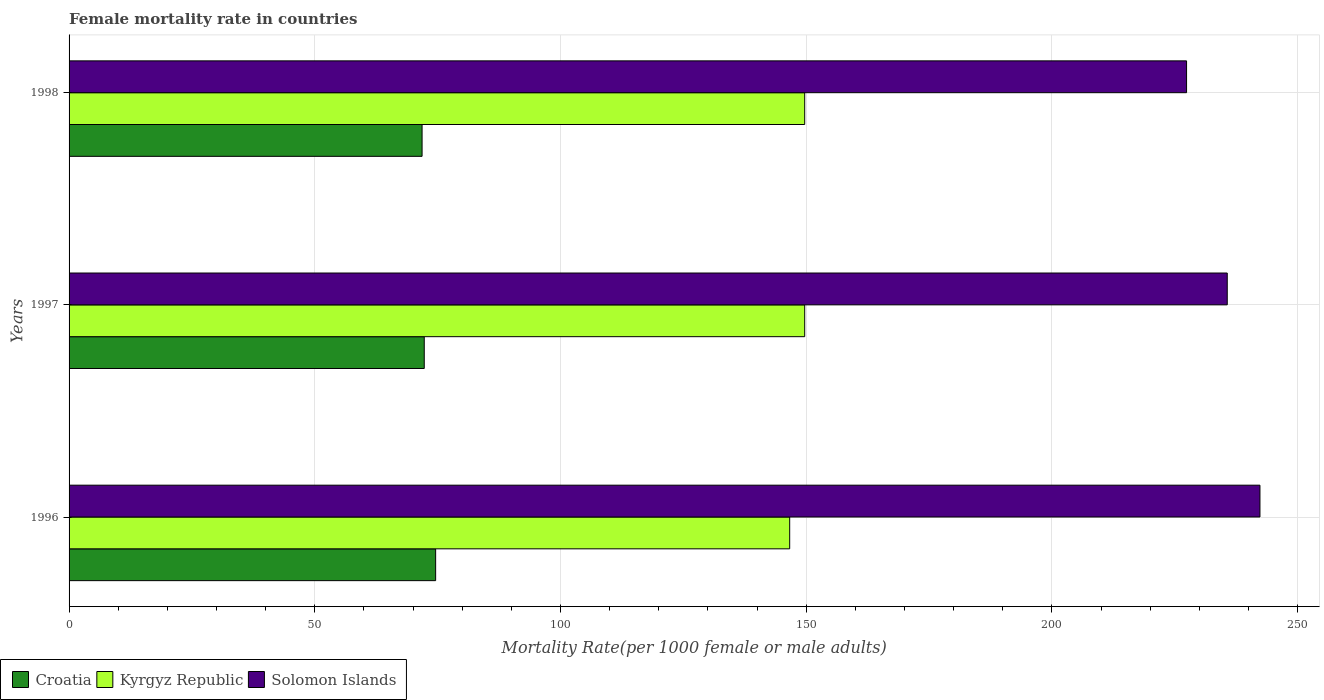How many groups of bars are there?
Give a very brief answer. 3. How many bars are there on the 2nd tick from the bottom?
Provide a succinct answer. 3. What is the label of the 3rd group of bars from the top?
Provide a short and direct response. 1996. In how many cases, is the number of bars for a given year not equal to the number of legend labels?
Your answer should be compact. 0. What is the female mortality rate in Solomon Islands in 1998?
Provide a succinct answer. 227.39. Across all years, what is the maximum female mortality rate in Solomon Islands?
Offer a terse response. 242.32. Across all years, what is the minimum female mortality rate in Croatia?
Offer a terse response. 71.83. In which year was the female mortality rate in Kyrgyz Republic maximum?
Your response must be concise. 1997. What is the total female mortality rate in Croatia in the graph?
Your response must be concise. 218.69. What is the difference between the female mortality rate in Croatia in 1996 and that in 1997?
Your answer should be very brief. 2.32. What is the difference between the female mortality rate in Kyrgyz Republic in 1996 and the female mortality rate in Croatia in 1998?
Ensure brevity in your answer.  74.8. What is the average female mortality rate in Solomon Islands per year?
Keep it short and to the point. 235.12. In the year 1997, what is the difference between the female mortality rate in Croatia and female mortality rate in Solomon Islands?
Your response must be concise. -163.39. What is the ratio of the female mortality rate in Croatia in 1997 to that in 1998?
Keep it short and to the point. 1.01. Is the female mortality rate in Kyrgyz Republic in 1997 less than that in 1998?
Ensure brevity in your answer.  No. What is the difference between the highest and the second highest female mortality rate in Solomon Islands?
Give a very brief answer. 6.66. What is the difference between the highest and the lowest female mortality rate in Solomon Islands?
Make the answer very short. 14.93. In how many years, is the female mortality rate in Solomon Islands greater than the average female mortality rate in Solomon Islands taken over all years?
Ensure brevity in your answer.  2. What does the 3rd bar from the top in 1997 represents?
Make the answer very short. Croatia. What does the 1st bar from the bottom in 1998 represents?
Your answer should be compact. Croatia. Is it the case that in every year, the sum of the female mortality rate in Croatia and female mortality rate in Kyrgyz Republic is greater than the female mortality rate in Solomon Islands?
Provide a short and direct response. No. How many years are there in the graph?
Your answer should be compact. 3. What is the difference between two consecutive major ticks on the X-axis?
Provide a short and direct response. 50. Are the values on the major ticks of X-axis written in scientific E-notation?
Keep it short and to the point. No. Does the graph contain grids?
Ensure brevity in your answer.  Yes. What is the title of the graph?
Provide a short and direct response. Female mortality rate in countries. Does "United States" appear as one of the legend labels in the graph?
Provide a short and direct response. No. What is the label or title of the X-axis?
Make the answer very short. Mortality Rate(per 1000 female or male adults). What is the Mortality Rate(per 1000 female or male adults) of Croatia in 1996?
Make the answer very short. 74.59. What is the Mortality Rate(per 1000 female or male adults) in Kyrgyz Republic in 1996?
Give a very brief answer. 146.63. What is the Mortality Rate(per 1000 female or male adults) in Solomon Islands in 1996?
Your answer should be compact. 242.32. What is the Mortality Rate(per 1000 female or male adults) in Croatia in 1997?
Ensure brevity in your answer.  72.27. What is the Mortality Rate(per 1000 female or male adults) in Kyrgyz Republic in 1997?
Your answer should be compact. 149.68. What is the Mortality Rate(per 1000 female or male adults) of Solomon Islands in 1997?
Provide a succinct answer. 235.66. What is the Mortality Rate(per 1000 female or male adults) of Croatia in 1998?
Provide a succinct answer. 71.83. What is the Mortality Rate(per 1000 female or male adults) of Kyrgyz Republic in 1998?
Provide a short and direct response. 149.68. What is the Mortality Rate(per 1000 female or male adults) in Solomon Islands in 1998?
Your answer should be compact. 227.39. Across all years, what is the maximum Mortality Rate(per 1000 female or male adults) of Croatia?
Your answer should be very brief. 74.59. Across all years, what is the maximum Mortality Rate(per 1000 female or male adults) of Kyrgyz Republic?
Make the answer very short. 149.68. Across all years, what is the maximum Mortality Rate(per 1000 female or male adults) in Solomon Islands?
Offer a very short reply. 242.32. Across all years, what is the minimum Mortality Rate(per 1000 female or male adults) in Croatia?
Your answer should be compact. 71.83. Across all years, what is the minimum Mortality Rate(per 1000 female or male adults) in Kyrgyz Republic?
Keep it short and to the point. 146.63. Across all years, what is the minimum Mortality Rate(per 1000 female or male adults) in Solomon Islands?
Keep it short and to the point. 227.39. What is the total Mortality Rate(per 1000 female or male adults) of Croatia in the graph?
Your response must be concise. 218.69. What is the total Mortality Rate(per 1000 female or male adults) of Kyrgyz Republic in the graph?
Your answer should be very brief. 446. What is the total Mortality Rate(per 1000 female or male adults) in Solomon Islands in the graph?
Make the answer very short. 705.37. What is the difference between the Mortality Rate(per 1000 female or male adults) of Croatia in 1996 and that in 1997?
Provide a short and direct response. 2.32. What is the difference between the Mortality Rate(per 1000 female or male adults) in Kyrgyz Republic in 1996 and that in 1997?
Keep it short and to the point. -3.05. What is the difference between the Mortality Rate(per 1000 female or male adults) in Solomon Islands in 1996 and that in 1997?
Provide a short and direct response. 6.66. What is the difference between the Mortality Rate(per 1000 female or male adults) in Croatia in 1996 and that in 1998?
Provide a short and direct response. 2.76. What is the difference between the Mortality Rate(per 1000 female or male adults) in Kyrgyz Republic in 1996 and that in 1998?
Provide a short and direct response. -3.05. What is the difference between the Mortality Rate(per 1000 female or male adults) of Solomon Islands in 1996 and that in 1998?
Offer a very short reply. 14.93. What is the difference between the Mortality Rate(per 1000 female or male adults) of Croatia in 1997 and that in 1998?
Offer a very short reply. 0.44. What is the difference between the Mortality Rate(per 1000 female or male adults) of Solomon Islands in 1997 and that in 1998?
Offer a very short reply. 8.28. What is the difference between the Mortality Rate(per 1000 female or male adults) of Croatia in 1996 and the Mortality Rate(per 1000 female or male adults) of Kyrgyz Republic in 1997?
Provide a succinct answer. -75.1. What is the difference between the Mortality Rate(per 1000 female or male adults) in Croatia in 1996 and the Mortality Rate(per 1000 female or male adults) in Solomon Islands in 1997?
Your response must be concise. -161.07. What is the difference between the Mortality Rate(per 1000 female or male adults) of Kyrgyz Republic in 1996 and the Mortality Rate(per 1000 female or male adults) of Solomon Islands in 1997?
Make the answer very short. -89.03. What is the difference between the Mortality Rate(per 1000 female or male adults) of Croatia in 1996 and the Mortality Rate(per 1000 female or male adults) of Kyrgyz Republic in 1998?
Make the answer very short. -75.1. What is the difference between the Mortality Rate(per 1000 female or male adults) of Croatia in 1996 and the Mortality Rate(per 1000 female or male adults) of Solomon Islands in 1998?
Offer a very short reply. -152.8. What is the difference between the Mortality Rate(per 1000 female or male adults) in Kyrgyz Republic in 1996 and the Mortality Rate(per 1000 female or male adults) in Solomon Islands in 1998?
Your response must be concise. -80.76. What is the difference between the Mortality Rate(per 1000 female or male adults) of Croatia in 1997 and the Mortality Rate(per 1000 female or male adults) of Kyrgyz Republic in 1998?
Your answer should be compact. -77.41. What is the difference between the Mortality Rate(per 1000 female or male adults) in Croatia in 1997 and the Mortality Rate(per 1000 female or male adults) in Solomon Islands in 1998?
Provide a short and direct response. -155.12. What is the difference between the Mortality Rate(per 1000 female or male adults) in Kyrgyz Republic in 1997 and the Mortality Rate(per 1000 female or male adults) in Solomon Islands in 1998?
Offer a terse response. -77.7. What is the average Mortality Rate(per 1000 female or male adults) in Croatia per year?
Offer a terse response. 72.9. What is the average Mortality Rate(per 1000 female or male adults) in Kyrgyz Republic per year?
Give a very brief answer. 148.67. What is the average Mortality Rate(per 1000 female or male adults) of Solomon Islands per year?
Give a very brief answer. 235.12. In the year 1996, what is the difference between the Mortality Rate(per 1000 female or male adults) of Croatia and Mortality Rate(per 1000 female or male adults) of Kyrgyz Republic?
Provide a short and direct response. -72.04. In the year 1996, what is the difference between the Mortality Rate(per 1000 female or male adults) in Croatia and Mortality Rate(per 1000 female or male adults) in Solomon Islands?
Your response must be concise. -167.73. In the year 1996, what is the difference between the Mortality Rate(per 1000 female or male adults) in Kyrgyz Republic and Mortality Rate(per 1000 female or male adults) in Solomon Islands?
Offer a terse response. -95.69. In the year 1997, what is the difference between the Mortality Rate(per 1000 female or male adults) of Croatia and Mortality Rate(per 1000 female or male adults) of Kyrgyz Republic?
Your answer should be very brief. -77.41. In the year 1997, what is the difference between the Mortality Rate(per 1000 female or male adults) of Croatia and Mortality Rate(per 1000 female or male adults) of Solomon Islands?
Make the answer very short. -163.39. In the year 1997, what is the difference between the Mortality Rate(per 1000 female or male adults) in Kyrgyz Republic and Mortality Rate(per 1000 female or male adults) in Solomon Islands?
Give a very brief answer. -85.98. In the year 1998, what is the difference between the Mortality Rate(per 1000 female or male adults) of Croatia and Mortality Rate(per 1000 female or male adults) of Kyrgyz Republic?
Make the answer very short. -77.85. In the year 1998, what is the difference between the Mortality Rate(per 1000 female or male adults) in Croatia and Mortality Rate(per 1000 female or male adults) in Solomon Islands?
Your answer should be compact. -155.56. In the year 1998, what is the difference between the Mortality Rate(per 1000 female or male adults) in Kyrgyz Republic and Mortality Rate(per 1000 female or male adults) in Solomon Islands?
Provide a succinct answer. -77.7. What is the ratio of the Mortality Rate(per 1000 female or male adults) of Croatia in 1996 to that in 1997?
Ensure brevity in your answer.  1.03. What is the ratio of the Mortality Rate(per 1000 female or male adults) of Kyrgyz Republic in 1996 to that in 1997?
Provide a succinct answer. 0.98. What is the ratio of the Mortality Rate(per 1000 female or male adults) in Solomon Islands in 1996 to that in 1997?
Ensure brevity in your answer.  1.03. What is the ratio of the Mortality Rate(per 1000 female or male adults) in Croatia in 1996 to that in 1998?
Offer a very short reply. 1.04. What is the ratio of the Mortality Rate(per 1000 female or male adults) in Kyrgyz Republic in 1996 to that in 1998?
Provide a short and direct response. 0.98. What is the ratio of the Mortality Rate(per 1000 female or male adults) in Solomon Islands in 1996 to that in 1998?
Offer a very short reply. 1.07. What is the ratio of the Mortality Rate(per 1000 female or male adults) of Croatia in 1997 to that in 1998?
Ensure brevity in your answer.  1.01. What is the ratio of the Mortality Rate(per 1000 female or male adults) in Solomon Islands in 1997 to that in 1998?
Offer a very short reply. 1.04. What is the difference between the highest and the second highest Mortality Rate(per 1000 female or male adults) of Croatia?
Give a very brief answer. 2.32. What is the difference between the highest and the second highest Mortality Rate(per 1000 female or male adults) in Solomon Islands?
Provide a succinct answer. 6.66. What is the difference between the highest and the lowest Mortality Rate(per 1000 female or male adults) in Croatia?
Make the answer very short. 2.76. What is the difference between the highest and the lowest Mortality Rate(per 1000 female or male adults) in Kyrgyz Republic?
Provide a succinct answer. 3.05. What is the difference between the highest and the lowest Mortality Rate(per 1000 female or male adults) of Solomon Islands?
Ensure brevity in your answer.  14.93. 